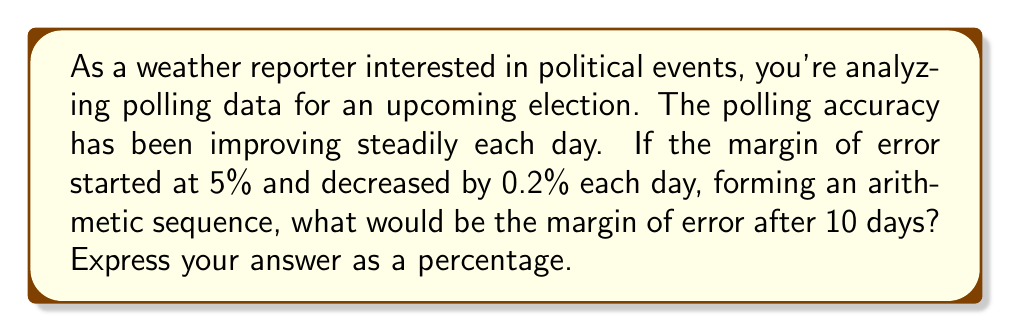Solve this math problem. Let's approach this step-by-step using the properties of arithmetic sequences:

1) We're dealing with an arithmetic sequence where:
   - The first term, $a_1 = 5\%$ (initial margin of error)
   - The common difference, $d = -0.2\%$ (it's negative because the margin is decreasing)
   - We want to find the 11th term (after 10 days)

2) The formula for the nth term of an arithmetic sequence is:
   $a_n = a_1 + (n-1)d$

3) In this case, we're looking for the 11th term, so n = 11:
   $a_{11} = 5 + (11-1)(-0.2)$

4) Simplify:
   $a_{11} = 5 + (10)(-0.2)$
   $a_{11} = 5 - 2$
   $a_{11} = 3$

5) Therefore, after 10 days, the margin of error would be 3%.
Answer: 3% 